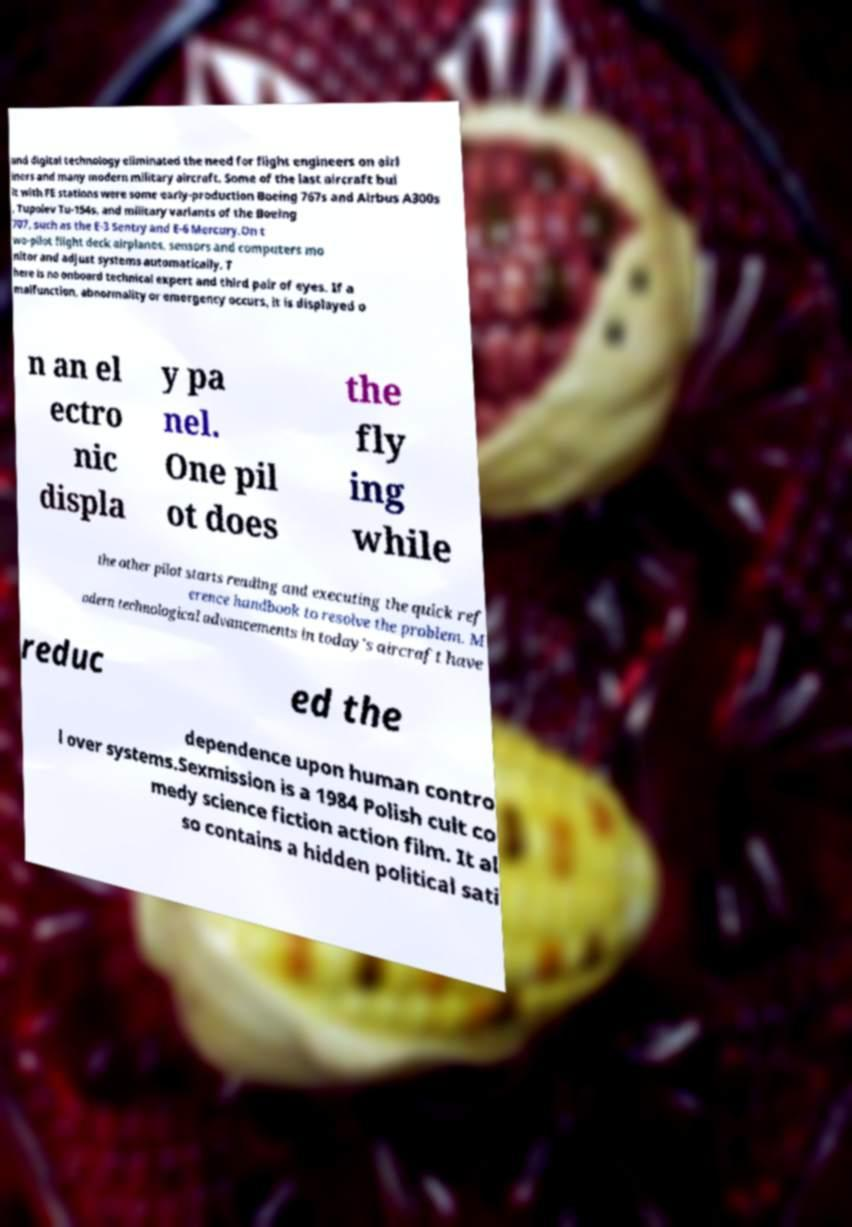Can you read and provide the text displayed in the image?This photo seems to have some interesting text. Can you extract and type it out for me? and digital technology eliminated the need for flight engineers on airl iners and many modern military aircraft. Some of the last aircraft bui lt with FE stations were some early-production Boeing 767s and Airbus A300s , Tupolev Tu-154s, and military variants of the Boeing 707, such as the E-3 Sentry and E-6 Mercury.On t wo-pilot flight deck airplanes, sensors and computers mo nitor and adjust systems automatically. T here is no onboard technical expert and third pair of eyes. If a malfunction, abnormality or emergency occurs, it is displayed o n an el ectro nic displa y pa nel. One pil ot does the fly ing while the other pilot starts reading and executing the quick ref erence handbook to resolve the problem. M odern technological advancements in today's aircraft have reduc ed the dependence upon human contro l over systems.Sexmission is a 1984 Polish cult co medy science fiction action film. It al so contains a hidden political sati 